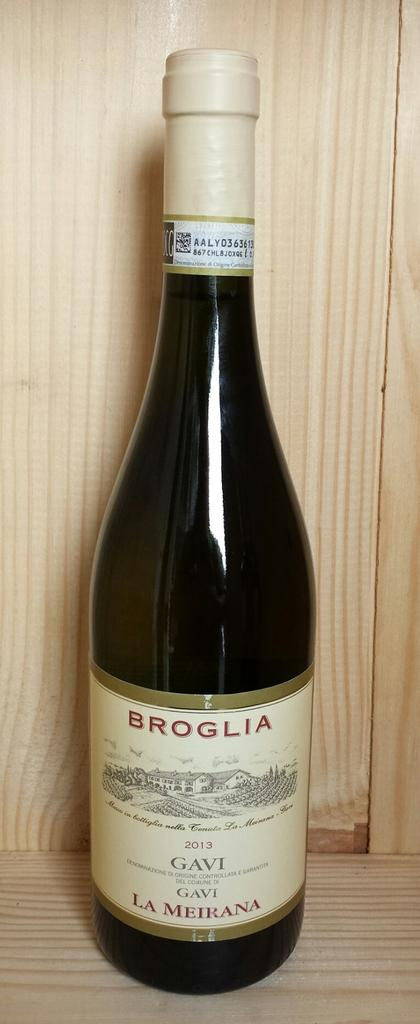<image>
Summarize the visual content of the image. A bottle of 2013 Broglia wine stands alone on a pine shelf. 